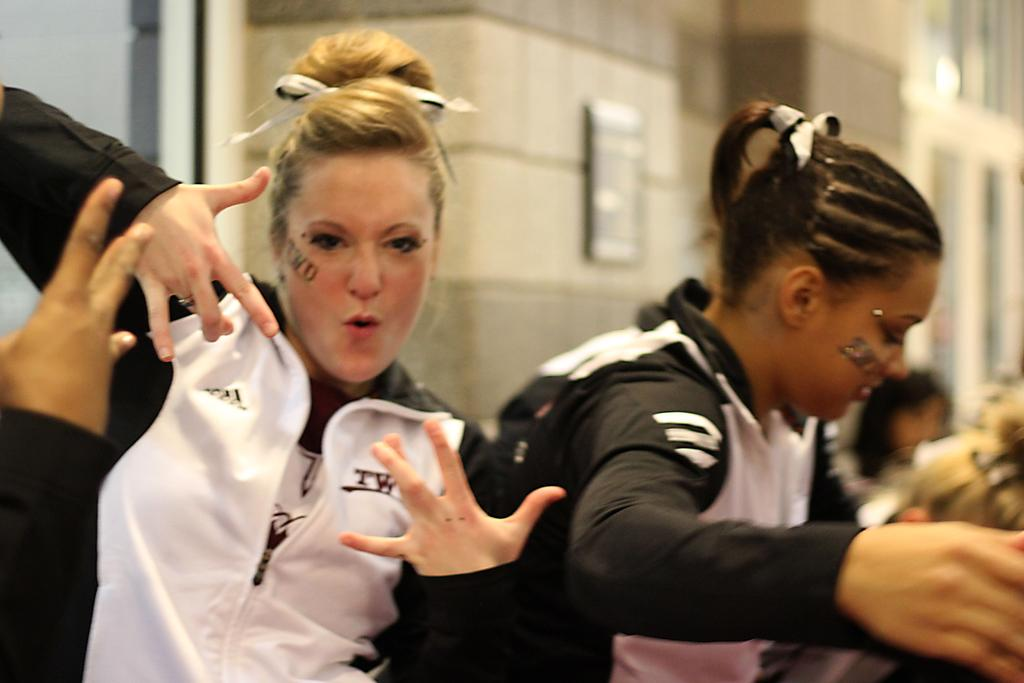Who or what is present in the image? There are people in the image. What can be seen in the distance behind the people? There is a building in the background of the image. What is on the building? There is a board on the building. How many ants can be seen on the board in the image? There are no ants present in the image. What is the purpose of the people in the image? The purpose of the people in the image cannot be determined from the provided facts. 